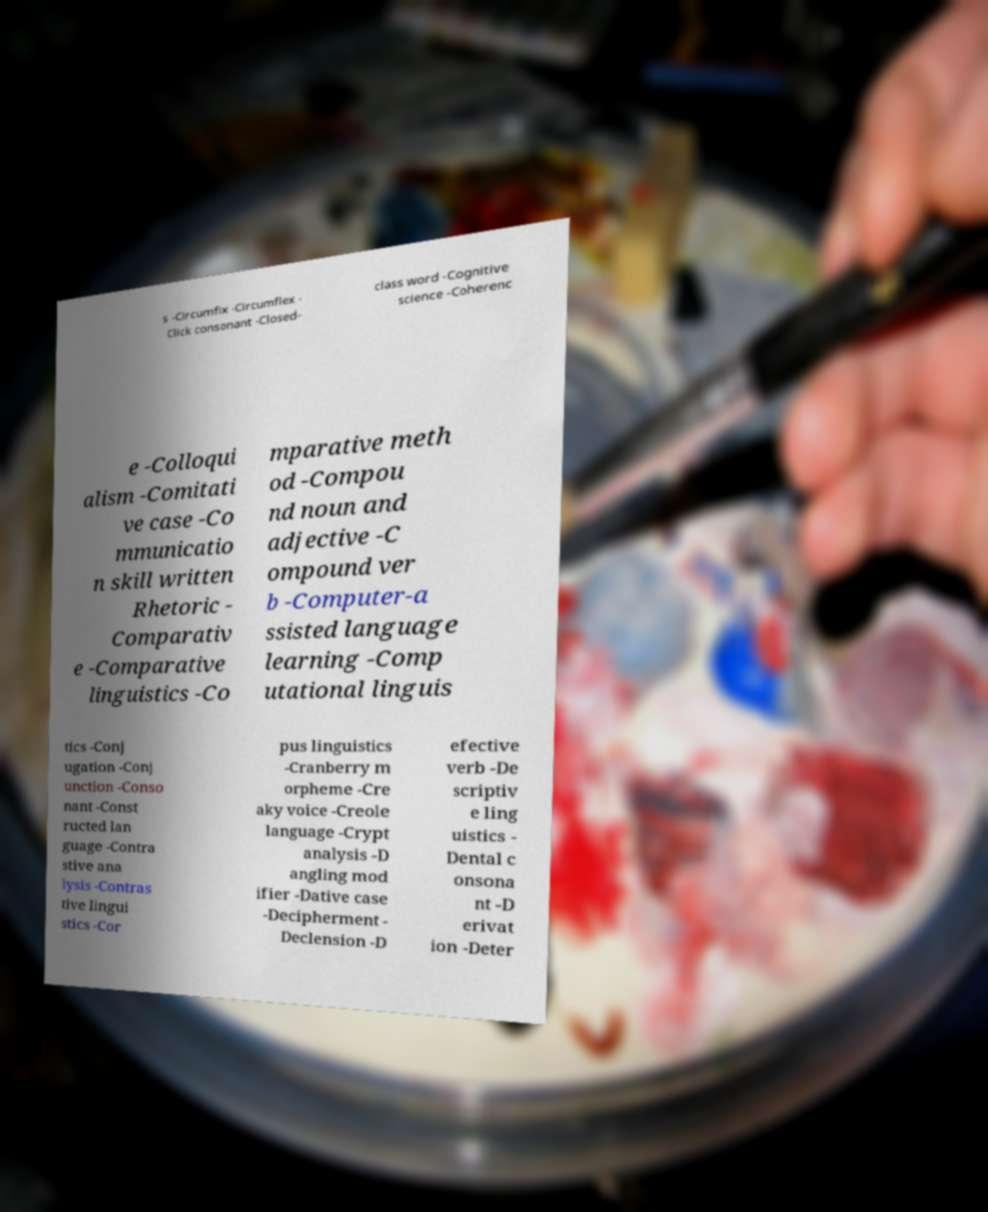I need the written content from this picture converted into text. Can you do that? s -Circumfix -Circumflex - Click consonant -Closed- class word -Cognitive science -Coherenc e -Colloqui alism -Comitati ve case -Co mmunicatio n skill written Rhetoric - Comparativ e -Comparative linguistics -Co mparative meth od -Compou nd noun and adjective -C ompound ver b -Computer-a ssisted language learning -Comp utational linguis tics -Conj ugation -Conj unction -Conso nant -Const ructed lan guage -Contra stive ana lysis -Contras tive lingui stics -Cor pus linguistics -Cranberry m orpheme -Cre aky voice -Creole language -Crypt analysis -D angling mod ifier -Dative case -Decipherment - Declension -D efective verb -De scriptiv e ling uistics - Dental c onsona nt -D erivat ion -Deter 